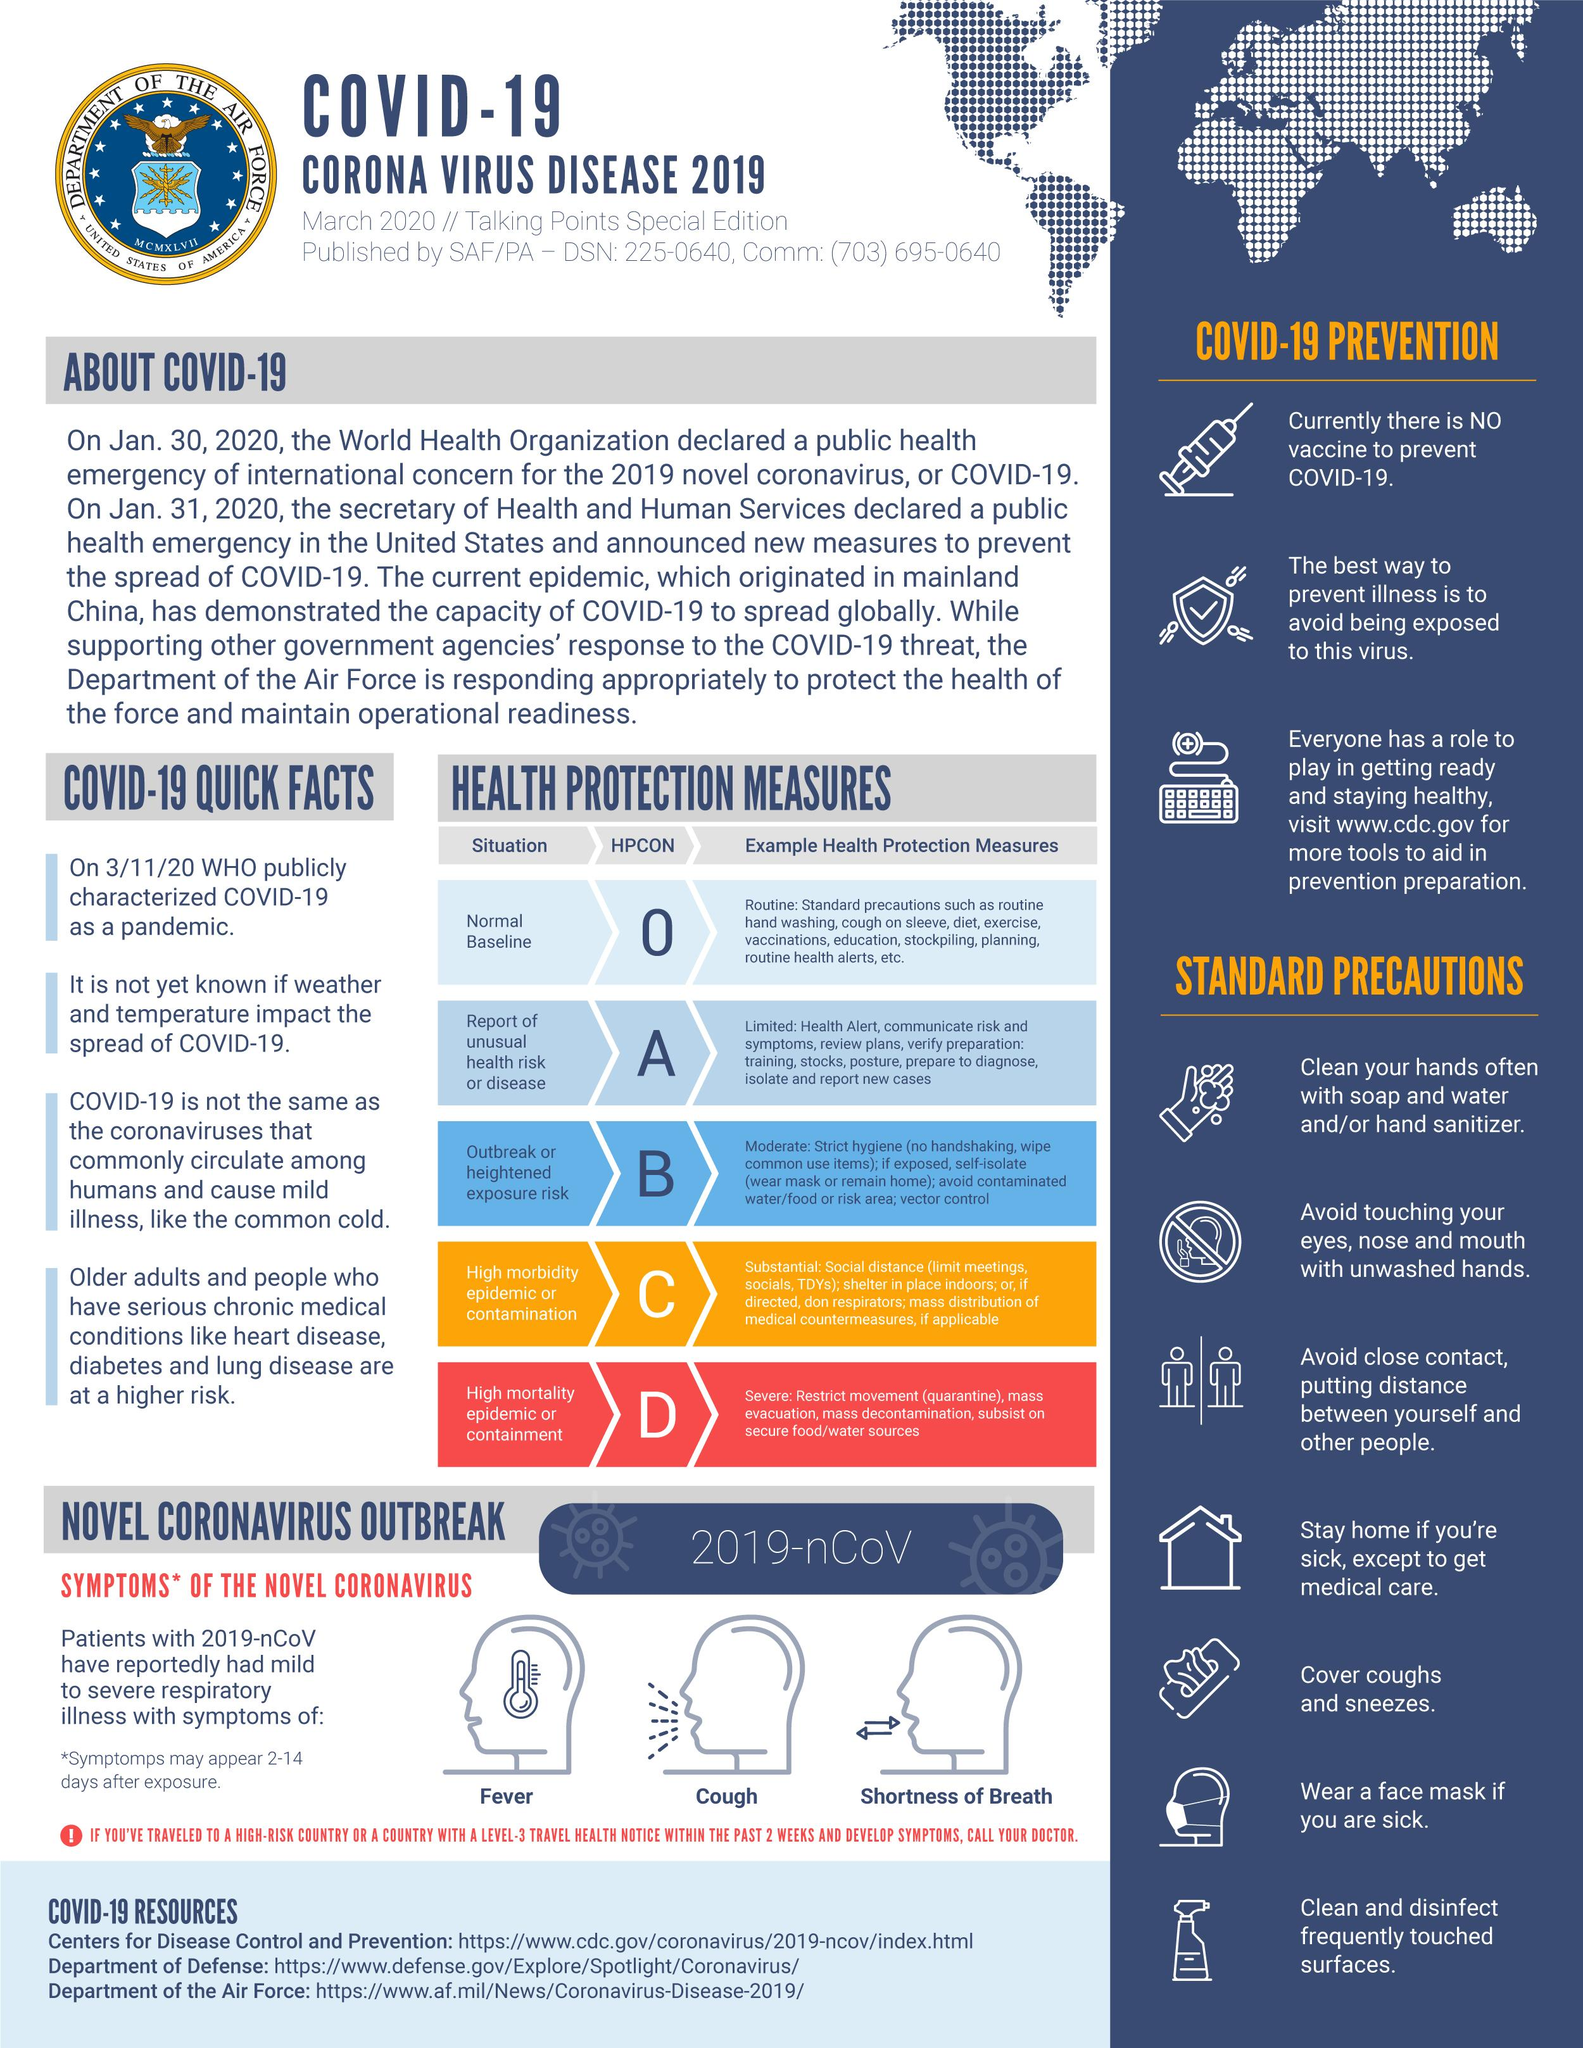Mention a couple of crucial points in this snapshot. The sixth standard precaution mentioned is wearing a face mask if one is sick. HPCON O is applicable for routine health protection measures. HPCON C is appropriate for situations characterized by high morbidity due to an epidemic or contamination. The HPCON is a set of guidelines for managing high mortality epidemics or containment situations. There are 7 'standard precautions' mentioned in this text. 